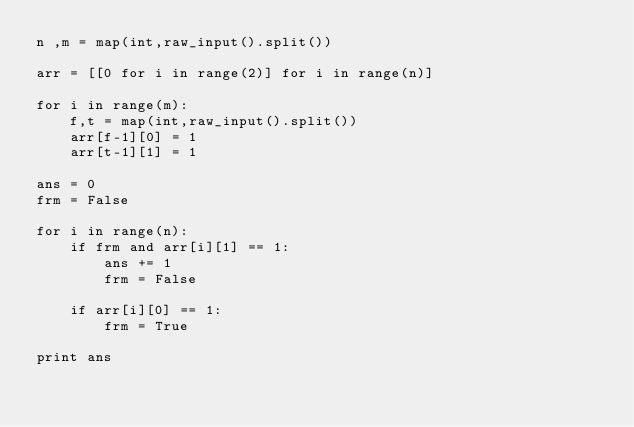Convert code to text. <code><loc_0><loc_0><loc_500><loc_500><_Python_>n ,m = map(int,raw_input().split())

arr = [[0 for i in range(2)] for i in range(n)]

for i in range(m):
	f,t = map(int,raw_input().split())
	arr[f-1][0] = 1
	arr[t-1][1] = 1	

ans = 0
frm = False

for i in range(n):
	if frm and arr[i][1] == 1:
		ans += 1
		frm = False

	if arr[i][0] == 1:
		frm = True

print ans
</code> 